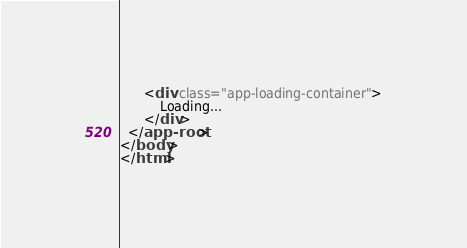<code> <loc_0><loc_0><loc_500><loc_500><_HTML_>	  <div class="app-loading-container">
		  Loading...
	  </div>
  </app-root>
</body>
</html>
</code> 